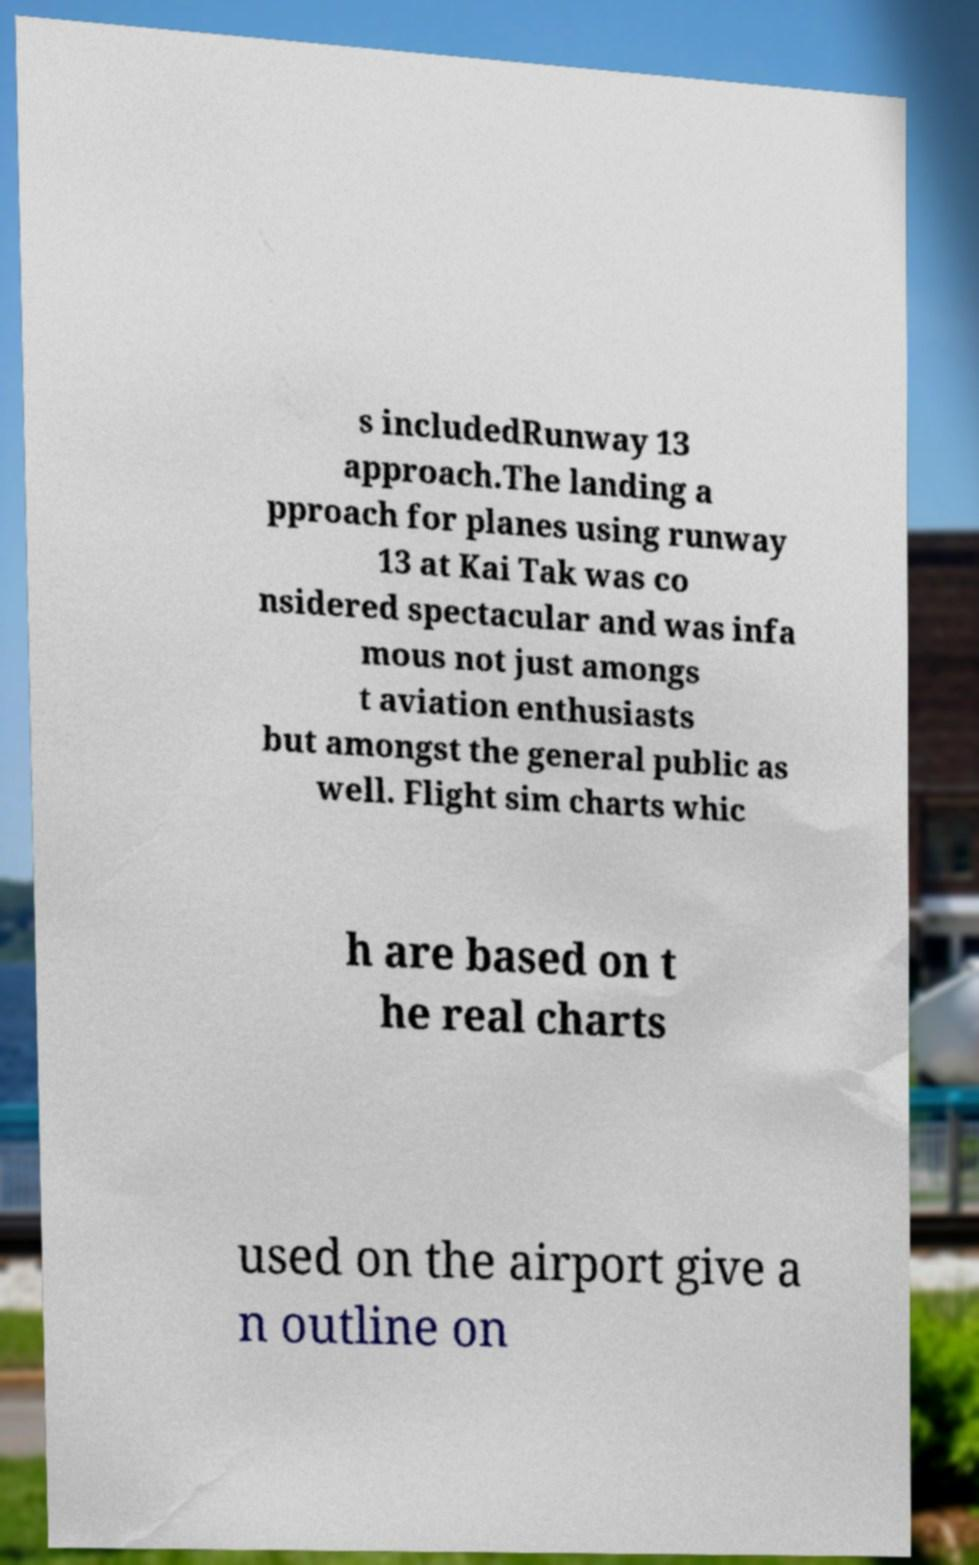Could you extract and type out the text from this image? s includedRunway 13 approach.The landing a pproach for planes using runway 13 at Kai Tak was co nsidered spectacular and was infa mous not just amongs t aviation enthusiasts but amongst the general public as well. Flight sim charts whic h are based on t he real charts used on the airport give a n outline on 